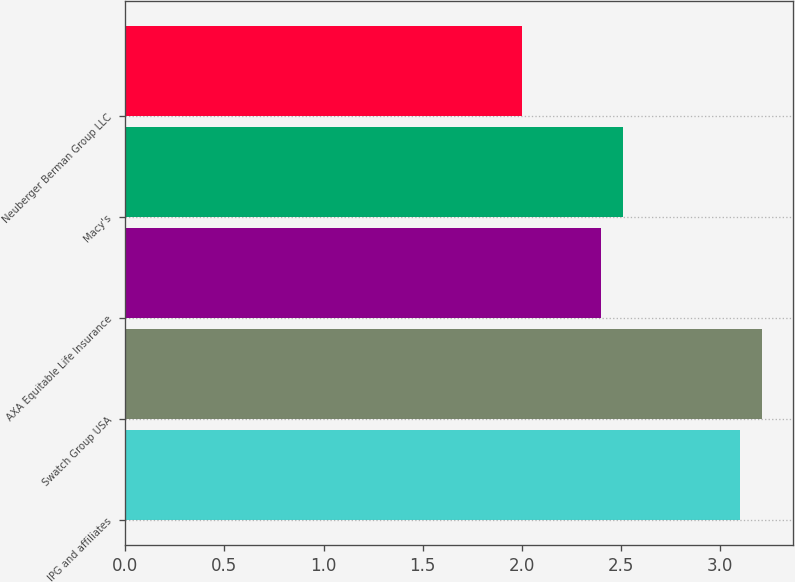Convert chart. <chart><loc_0><loc_0><loc_500><loc_500><bar_chart><fcel>IPG and affiliates<fcel>Swatch Group USA<fcel>AXA Equitable Life Insurance<fcel>Macy's<fcel>Neuberger Berman Group LLC<nl><fcel>3.1<fcel>3.21<fcel>2.4<fcel>2.51<fcel>2<nl></chart> 